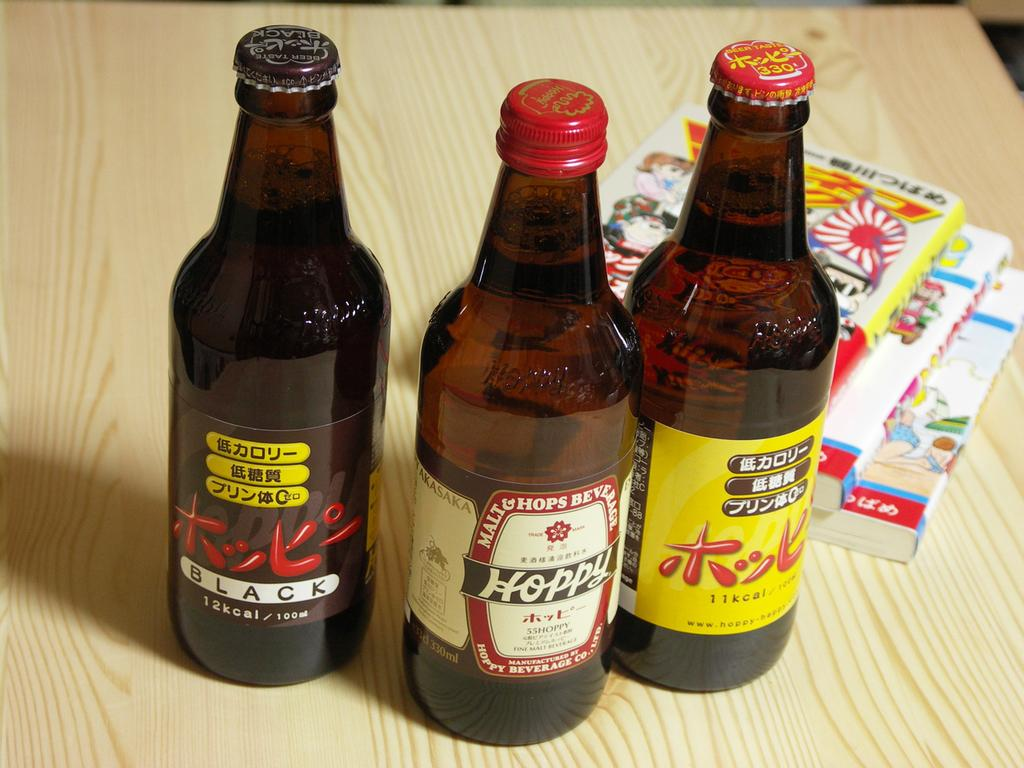<image>
Present a compact description of the photo's key features. Three bottles of Chinese beers labeled Black and Hoppy. 